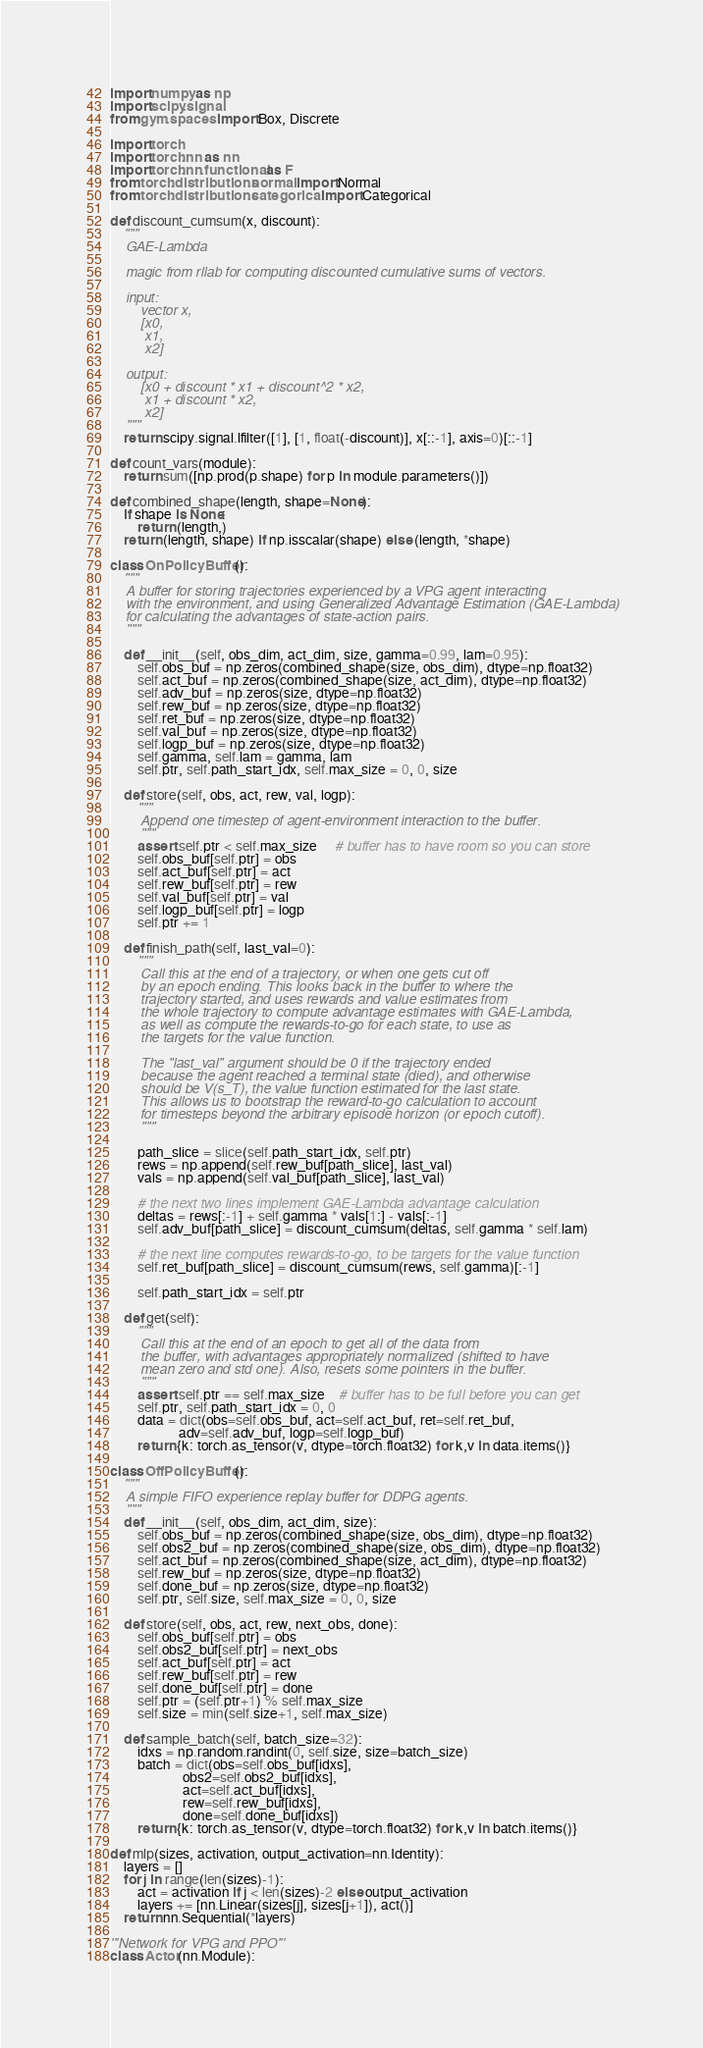Convert code to text. <code><loc_0><loc_0><loc_500><loc_500><_Python_>import numpy as np
import scipy.signal
from gym.spaces import Box, Discrete

import torch
import torch.nn as nn
import torch.nn.functional as F
from torch.distributions.normal import Normal
from torch.distributions.categorical import Categorical

def discount_cumsum(x, discount):
    """
    GAE-Lambda

    magic from rllab for computing discounted cumulative sums of vectors.

    input: 
        vector x, 
        [x0, 
         x1, 
         x2]

    output:
        [x0 + discount * x1 + discount^2 * x2,  
         x1 + discount * x2,
         x2]
    """
    return scipy.signal.lfilter([1], [1, float(-discount)], x[::-1], axis=0)[::-1]

def count_vars(module):
    return sum([np.prod(p.shape) for p in module.parameters()])

def combined_shape(length, shape=None):
    if shape is None:
        return (length,)
    return (length, shape) if np.isscalar(shape) else (length, *shape)

class OnPolicyBuffer():
    """
    A buffer for storing trajectories experienced by a VPG agent interacting
    with the environment, and using Generalized Advantage Estimation (GAE-Lambda)
    for calculating the advantages of state-action pairs.
    """

    def __init__(self, obs_dim, act_dim, size, gamma=0.99, lam=0.95):
        self.obs_buf = np.zeros(combined_shape(size, obs_dim), dtype=np.float32)
        self.act_buf = np.zeros(combined_shape(size, act_dim), dtype=np.float32)
        self.adv_buf = np.zeros(size, dtype=np.float32)
        self.rew_buf = np.zeros(size, dtype=np.float32)
        self.ret_buf = np.zeros(size, dtype=np.float32)
        self.val_buf = np.zeros(size, dtype=np.float32)
        self.logp_buf = np.zeros(size, dtype=np.float32)
        self.gamma, self.lam = gamma, lam
        self.ptr, self.path_start_idx, self.max_size = 0, 0, size

    def store(self, obs, act, rew, val, logp):
        """
        Append one timestep of agent-environment interaction to the buffer.
        """
        assert self.ptr < self.max_size     # buffer has to have room so you can store
        self.obs_buf[self.ptr] = obs
        self.act_buf[self.ptr] = act
        self.rew_buf[self.ptr] = rew
        self.val_buf[self.ptr] = val
        self.logp_buf[self.ptr] = logp
        self.ptr += 1

    def finish_path(self, last_val=0):
        """
        Call this at the end of a trajectory, or when one gets cut off
        by an epoch ending. This looks back in the buffer to where the
        trajectory started, and uses rewards and value estimates from
        the whole trajectory to compute advantage estimates with GAE-Lambda,
        as well as compute the rewards-to-go for each state, to use as
        the targets for the value function.

        The "last_val" argument should be 0 if the trajectory ended
        because the agent reached a terminal state (died), and otherwise
        should be V(s_T), the value function estimated for the last state.
        This allows us to bootstrap the reward-to-go calculation to account
        for timesteps beyond the arbitrary episode horizon (or epoch cutoff).
        """

        path_slice = slice(self.path_start_idx, self.ptr)
        rews = np.append(self.rew_buf[path_slice], last_val)
        vals = np.append(self.val_buf[path_slice], last_val)
        
        # the next two lines implement GAE-Lambda advantage calculation
        deltas = rews[:-1] + self.gamma * vals[1:] - vals[:-1]
        self.adv_buf[path_slice] = discount_cumsum(deltas, self.gamma * self.lam)
        
        # the next line computes rewards-to-go, to be targets for the value function
        self.ret_buf[path_slice] = discount_cumsum(rews, self.gamma)[:-1]
        
        self.path_start_idx = self.ptr

    def get(self):
        """
        Call this at the end of an epoch to get all of the data from
        the buffer, with advantages appropriately normalized (shifted to have
        mean zero and std one). Also, resets some pointers in the buffer.
        """
        assert self.ptr == self.max_size    # buffer has to be full before you can get
        self.ptr, self.path_start_idx = 0, 0
        data = dict(obs=self.obs_buf, act=self.act_buf, ret=self.ret_buf,
                    adv=self.adv_buf, logp=self.logp_buf)
        return {k: torch.as_tensor(v, dtype=torch.float32) for k,v in data.items()}

class OffPolicyBuffer():
    """
    A simple FIFO experience replay buffer for DDPG agents.
    """
    def __init__(self, obs_dim, act_dim, size):
        self.obs_buf = np.zeros(combined_shape(size, obs_dim), dtype=np.float32)
        self.obs2_buf = np.zeros(combined_shape(size, obs_dim), dtype=np.float32)
        self.act_buf = np.zeros(combined_shape(size, act_dim), dtype=np.float32)
        self.rew_buf = np.zeros(size, dtype=np.float32)
        self.done_buf = np.zeros(size, dtype=np.float32)
        self.ptr, self.size, self.max_size = 0, 0, size

    def store(self, obs, act, rew, next_obs, done):
        self.obs_buf[self.ptr] = obs
        self.obs2_buf[self.ptr] = next_obs
        self.act_buf[self.ptr] = act
        self.rew_buf[self.ptr] = rew
        self.done_buf[self.ptr] = done
        self.ptr = (self.ptr+1) % self.max_size
        self.size = min(self.size+1, self.max_size)

    def sample_batch(self, batch_size=32):
        idxs = np.random.randint(0, self.size, size=batch_size)
        batch = dict(obs=self.obs_buf[idxs],
                     obs2=self.obs2_buf[idxs],
                     act=self.act_buf[idxs],
                     rew=self.rew_buf[idxs],
                     done=self.done_buf[idxs])
        return {k: torch.as_tensor(v, dtype=torch.float32) for k,v in batch.items()}

def mlp(sizes, activation, output_activation=nn.Identity):
    layers = []
    for j in range(len(sizes)-1):
        act = activation if j < len(sizes)-2 else output_activation
        layers += [nn.Linear(sizes[j], sizes[j+1]), act()]
    return nn.Sequential(*layers)

'''Network for VPG and PPO'''
class Actor(nn.Module):
</code> 